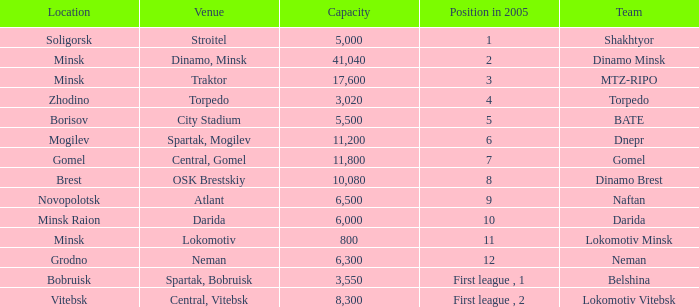Could you help me parse every detail presented in this table? {'header': ['Location', 'Venue', 'Capacity', 'Position in 2005', 'Team'], 'rows': [['Soligorsk', 'Stroitel', '5,000', '1', 'Shakhtyor'], ['Minsk', 'Dinamo, Minsk', '41,040', '2', 'Dinamo Minsk'], ['Minsk', 'Traktor', '17,600', '3', 'MTZ-RIPO'], ['Zhodino', 'Torpedo', '3,020', '4', 'Torpedo'], ['Borisov', 'City Stadium', '5,500', '5', 'BATE'], ['Mogilev', 'Spartak, Mogilev', '11,200', '6', 'Dnepr'], ['Gomel', 'Central, Gomel', '11,800', '7', 'Gomel'], ['Brest', 'OSK Brestskiy', '10,080', '8', 'Dinamo Brest'], ['Novopolotsk', 'Atlant', '6,500', '9', 'Naftan'], ['Minsk Raion', 'Darida', '6,000', '10', 'Darida'], ['Minsk', 'Lokomotiv', '800', '11', 'Lokomotiv Minsk'], ['Grodno', 'Neman', '6,300', '12', 'Neman'], ['Bobruisk', 'Spartak, Bobruisk', '3,550', 'First league , 1', 'Belshina'], ['Vitebsk', 'Central, Vitebsk', '8,300', 'First league , 2', 'Lokomotiv Vitebsk']]} Can you tell me the highest Capacity that has the Team of torpedo? 3020.0. 